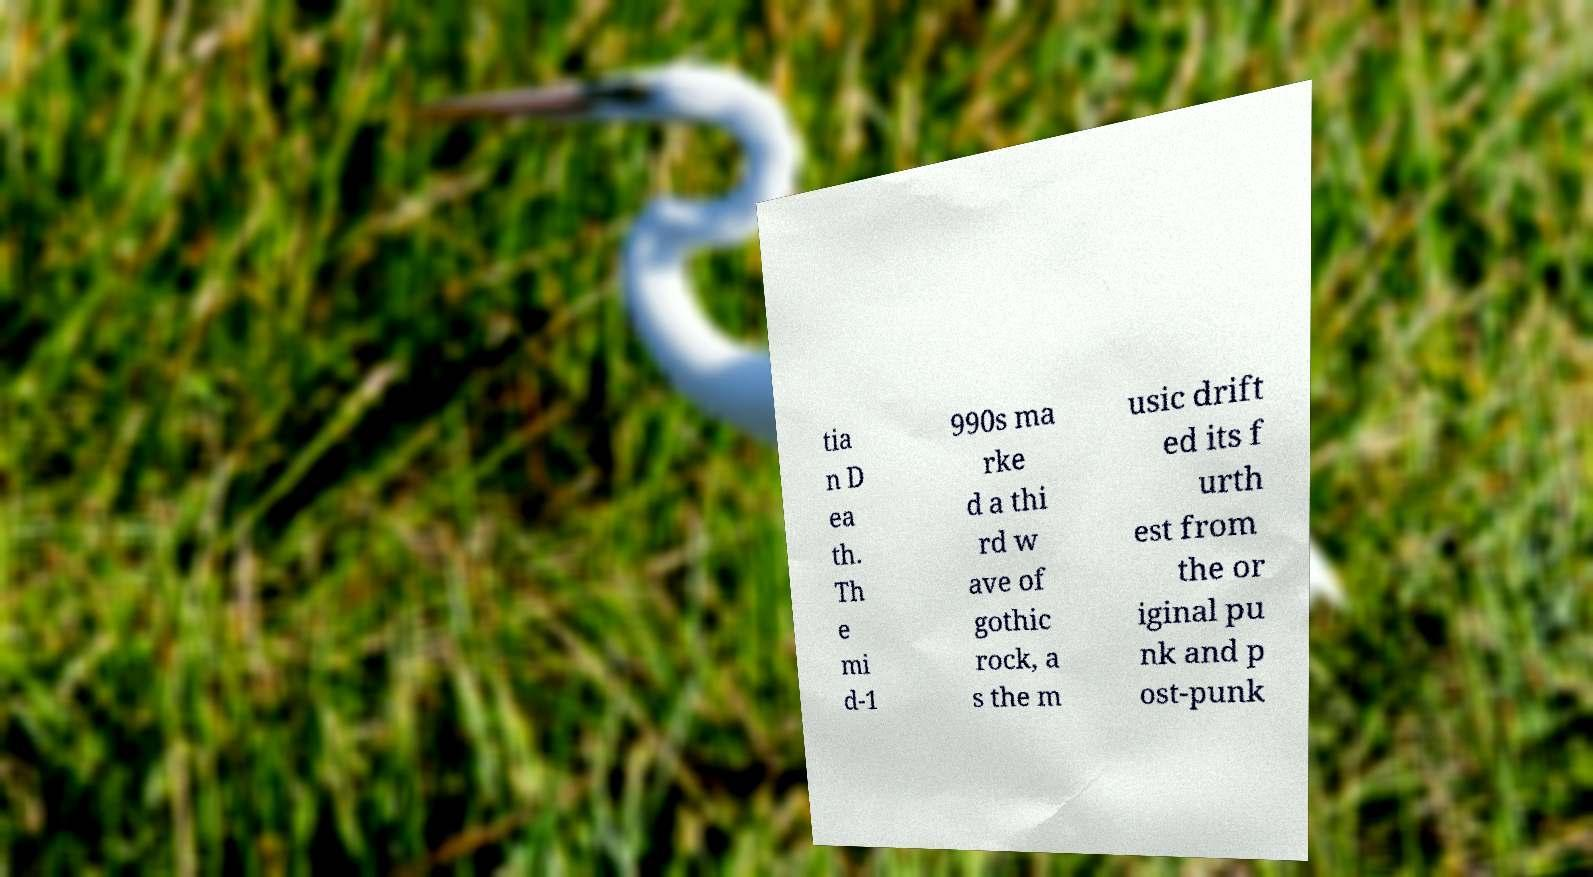Please read and relay the text visible in this image. What does it say? tia n D ea th. Th e mi d-1 990s ma rke d a thi rd w ave of gothic rock, a s the m usic drift ed its f urth est from the or iginal pu nk and p ost-punk 